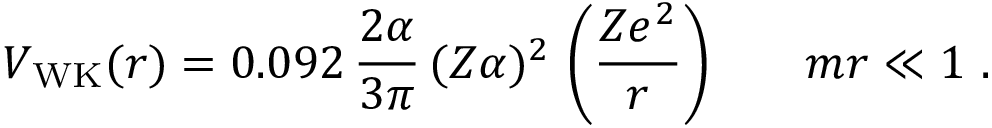Convert formula to latex. <formula><loc_0><loc_0><loc_500><loc_500>V _ { W K } ( r ) = 0 . 0 9 2 \, \frac { 2 \alpha } { 3 \pi } \, ( Z \alpha ) ^ { 2 } \, \left ( \frac { Z e ^ { 2 } } { r } \right ) \, m r \ll 1 .</formula> 